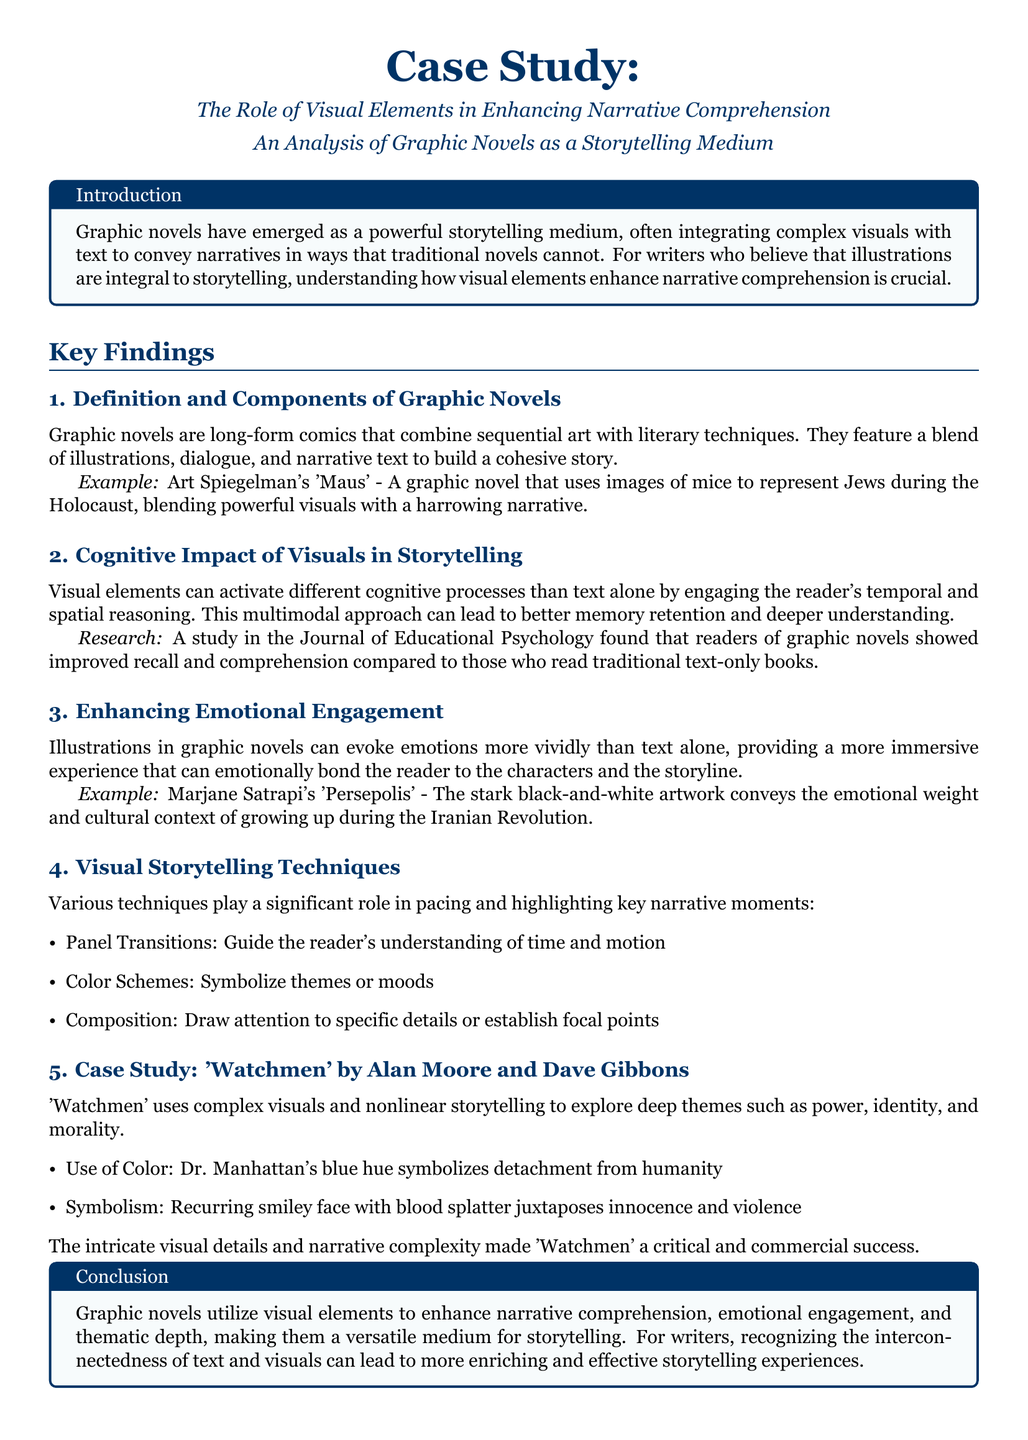what is the title of the case study? The title of the case study is stated in the document's header and highlights the main focus on visual elements in storytelling.
Answer: The Role of Visual Elements in Enhancing Narrative Comprehension who is the author of 'Maus'? The example provided in the document attributes 'Maus' to a specific author known for integrating powerful visuals with narrative.
Answer: Art Spiegelman what does visual storytelling enhance according to the document? The document outlines the benefits of visuals in storytelling, emphasizing how they contribute to a deeper understanding and emotional resonance.
Answer: Narrative comprehension name one graphic novel mentioned in the case study. The document lists several graphic novels, providing specific examples that illustrate its key points.
Answer: Persepolis what cognitive processes do visuals activate? The document discusses the type of reasoning engaged by visual elements, pointing out what they facilitate beyond text.
Answer: Temporal and spatial reasoning how does 'Watchmen' symbolize detachment from humanity? The case study examines the color choice of a character in 'Watchmen' as a significant symbol related to a theme of disconnection.
Answer: Blue hue what emotional aspect do illustrations evoke? The document details the effect visuals have on readers, particularly focusing on how they affect their emotional connection to the story.
Answer: Emotions which publication featured research on graphic novels' impact on comprehension? The source of the research finding mentioned in the document is critical for understanding the broader context of graphic novels.
Answer: Journal of Educational Psychology 